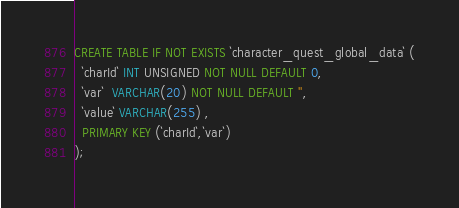Convert code to text. <code><loc_0><loc_0><loc_500><loc_500><_SQL_>CREATE TABLE IF NOT EXISTS `character_quest_global_data` (
  `charId` INT UNSIGNED NOT NULL DEFAULT 0,
  `var`  VARCHAR(20) NOT NULL DEFAULT '',
  `value` VARCHAR(255) ,
  PRIMARY KEY (`charId`,`var`)
);</code> 